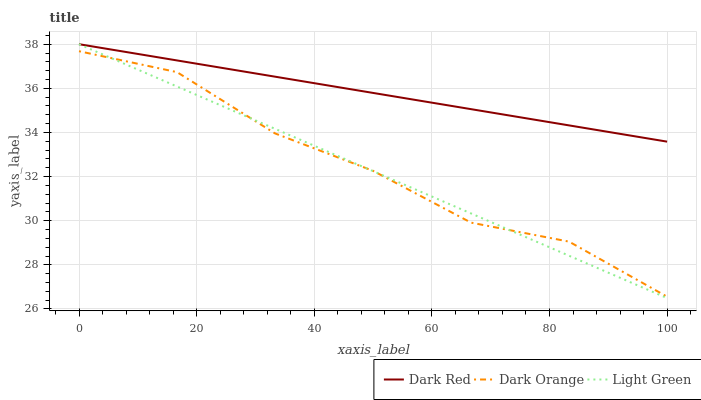Does Light Green have the minimum area under the curve?
Answer yes or no. Yes. Does Dark Red have the maximum area under the curve?
Answer yes or no. Yes. Does Dark Orange have the minimum area under the curve?
Answer yes or no. No. Does Dark Orange have the maximum area under the curve?
Answer yes or no. No. Is Dark Red the smoothest?
Answer yes or no. Yes. Is Dark Orange the roughest?
Answer yes or no. Yes. Is Light Green the smoothest?
Answer yes or no. No. Is Light Green the roughest?
Answer yes or no. No. Does Light Green have the lowest value?
Answer yes or no. Yes. Does Dark Orange have the lowest value?
Answer yes or no. No. Does Light Green have the highest value?
Answer yes or no. Yes. Does Dark Orange have the highest value?
Answer yes or no. No. Is Dark Orange less than Dark Red?
Answer yes or no. Yes. Is Dark Red greater than Dark Orange?
Answer yes or no. Yes. Does Light Green intersect Dark Orange?
Answer yes or no. Yes. Is Light Green less than Dark Orange?
Answer yes or no. No. Is Light Green greater than Dark Orange?
Answer yes or no. No. Does Dark Orange intersect Dark Red?
Answer yes or no. No. 